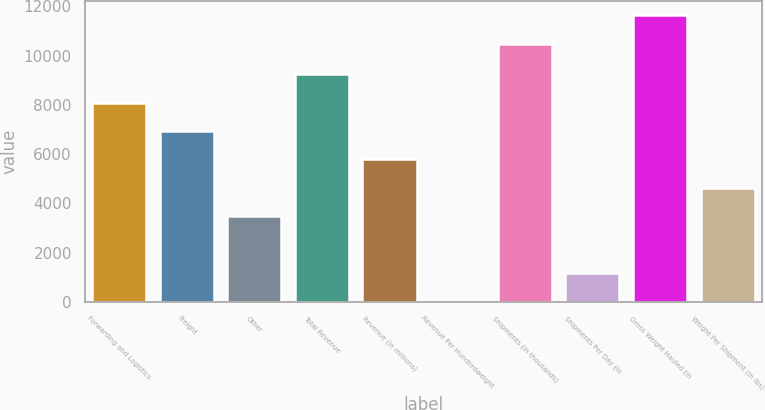<chart> <loc_0><loc_0><loc_500><loc_500><bar_chart><fcel>Forwarding and Logistics<fcel>Freight<fcel>Other<fcel>Total Revenue<fcel>Revenue (in millions)<fcel>Revenue Per Hundredweight<fcel>Shipments (in thousands)<fcel>Shipments Per Day (in<fcel>Gross Weight Hauled (in<fcel>Weight Per Shipment (in lbs)<nl><fcel>8097.23<fcel>6942.97<fcel>3480.19<fcel>9251.49<fcel>5788.71<fcel>17.41<fcel>10481<fcel>1171.67<fcel>11635.3<fcel>4634.45<nl></chart> 